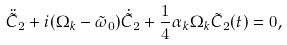<formula> <loc_0><loc_0><loc_500><loc_500>\ddot { \tilde { C } } _ { 2 } + i ( \Omega _ { k } - \tilde { \omega } _ { 0 } ) \dot { \tilde { C } } _ { 2 } + { \frac { 1 } { 4 } } \alpha _ { k } \Omega _ { k } \tilde { C } _ { 2 } ( t ) = 0 ,</formula> 